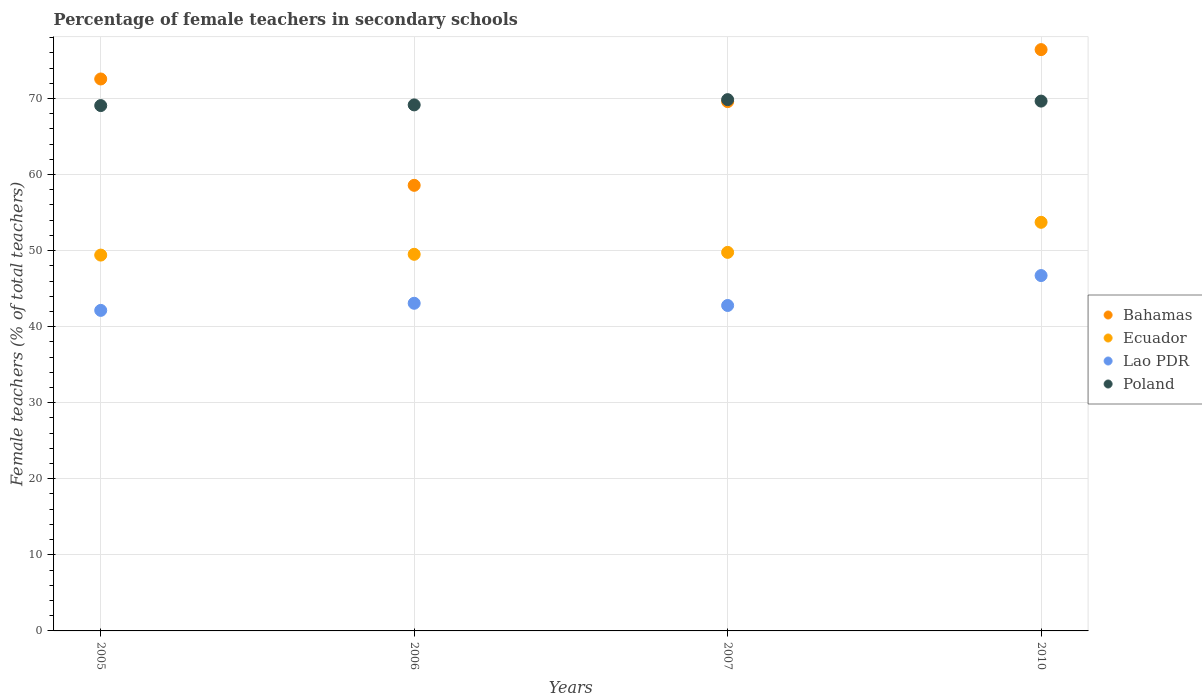Is the number of dotlines equal to the number of legend labels?
Provide a succinct answer. Yes. What is the percentage of female teachers in Ecuador in 2010?
Keep it short and to the point. 53.72. Across all years, what is the maximum percentage of female teachers in Lao PDR?
Offer a terse response. 46.72. Across all years, what is the minimum percentage of female teachers in Lao PDR?
Your answer should be compact. 42.14. In which year was the percentage of female teachers in Lao PDR maximum?
Offer a terse response. 2010. What is the total percentage of female teachers in Poland in the graph?
Your response must be concise. 277.71. What is the difference between the percentage of female teachers in Ecuador in 2005 and that in 2010?
Keep it short and to the point. -4.31. What is the difference between the percentage of female teachers in Lao PDR in 2006 and the percentage of female teachers in Ecuador in 2007?
Provide a short and direct response. -6.69. What is the average percentage of female teachers in Bahamas per year?
Your answer should be compact. 69.28. In the year 2005, what is the difference between the percentage of female teachers in Poland and percentage of female teachers in Ecuador?
Make the answer very short. 19.66. What is the ratio of the percentage of female teachers in Ecuador in 2007 to that in 2010?
Provide a short and direct response. 0.93. Is the difference between the percentage of female teachers in Poland in 2006 and 2007 greater than the difference between the percentage of female teachers in Ecuador in 2006 and 2007?
Your response must be concise. No. What is the difference between the highest and the second highest percentage of female teachers in Bahamas?
Provide a succinct answer. 3.86. What is the difference between the highest and the lowest percentage of female teachers in Lao PDR?
Provide a succinct answer. 4.58. In how many years, is the percentage of female teachers in Poland greater than the average percentage of female teachers in Poland taken over all years?
Your answer should be very brief. 2. Is it the case that in every year, the sum of the percentage of female teachers in Ecuador and percentage of female teachers in Lao PDR  is greater than the sum of percentage of female teachers in Bahamas and percentage of female teachers in Poland?
Your response must be concise. No. Does the percentage of female teachers in Ecuador monotonically increase over the years?
Your response must be concise. Yes. Is the percentage of female teachers in Bahamas strictly less than the percentage of female teachers in Ecuador over the years?
Offer a terse response. No. How many years are there in the graph?
Keep it short and to the point. 4. What is the difference between two consecutive major ticks on the Y-axis?
Provide a short and direct response. 10. Does the graph contain grids?
Keep it short and to the point. Yes. How many legend labels are there?
Offer a very short reply. 4. What is the title of the graph?
Provide a succinct answer. Percentage of female teachers in secondary schools. What is the label or title of the X-axis?
Ensure brevity in your answer.  Years. What is the label or title of the Y-axis?
Provide a short and direct response. Female teachers (% of total teachers). What is the Female teachers (% of total teachers) of Bahamas in 2005?
Provide a short and direct response. 72.56. What is the Female teachers (% of total teachers) in Ecuador in 2005?
Your answer should be compact. 49.41. What is the Female teachers (% of total teachers) in Lao PDR in 2005?
Ensure brevity in your answer.  42.14. What is the Female teachers (% of total teachers) of Poland in 2005?
Your answer should be compact. 69.06. What is the Female teachers (% of total teachers) of Bahamas in 2006?
Ensure brevity in your answer.  58.58. What is the Female teachers (% of total teachers) in Ecuador in 2006?
Keep it short and to the point. 49.51. What is the Female teachers (% of total teachers) in Lao PDR in 2006?
Provide a short and direct response. 43.07. What is the Female teachers (% of total teachers) of Poland in 2006?
Provide a succinct answer. 69.15. What is the Female teachers (% of total teachers) of Bahamas in 2007?
Provide a succinct answer. 69.58. What is the Female teachers (% of total teachers) of Ecuador in 2007?
Your answer should be compact. 49.76. What is the Female teachers (% of total teachers) of Lao PDR in 2007?
Your answer should be very brief. 42.78. What is the Female teachers (% of total teachers) in Poland in 2007?
Ensure brevity in your answer.  69.84. What is the Female teachers (% of total teachers) in Bahamas in 2010?
Give a very brief answer. 76.42. What is the Female teachers (% of total teachers) in Ecuador in 2010?
Your answer should be compact. 53.72. What is the Female teachers (% of total teachers) of Lao PDR in 2010?
Your answer should be compact. 46.72. What is the Female teachers (% of total teachers) in Poland in 2010?
Your answer should be compact. 69.65. Across all years, what is the maximum Female teachers (% of total teachers) of Bahamas?
Give a very brief answer. 76.42. Across all years, what is the maximum Female teachers (% of total teachers) of Ecuador?
Give a very brief answer. 53.72. Across all years, what is the maximum Female teachers (% of total teachers) of Lao PDR?
Keep it short and to the point. 46.72. Across all years, what is the maximum Female teachers (% of total teachers) of Poland?
Your answer should be very brief. 69.84. Across all years, what is the minimum Female teachers (% of total teachers) in Bahamas?
Ensure brevity in your answer.  58.58. Across all years, what is the minimum Female teachers (% of total teachers) in Ecuador?
Your answer should be very brief. 49.41. Across all years, what is the minimum Female teachers (% of total teachers) in Lao PDR?
Your response must be concise. 42.14. Across all years, what is the minimum Female teachers (% of total teachers) of Poland?
Give a very brief answer. 69.06. What is the total Female teachers (% of total teachers) in Bahamas in the graph?
Provide a short and direct response. 277.14. What is the total Female teachers (% of total teachers) in Ecuador in the graph?
Make the answer very short. 202.4. What is the total Female teachers (% of total teachers) in Lao PDR in the graph?
Your answer should be compact. 174.71. What is the total Female teachers (% of total teachers) in Poland in the graph?
Provide a succinct answer. 277.71. What is the difference between the Female teachers (% of total teachers) of Bahamas in 2005 and that in 2006?
Give a very brief answer. 13.98. What is the difference between the Female teachers (% of total teachers) of Ecuador in 2005 and that in 2006?
Your answer should be compact. -0.1. What is the difference between the Female teachers (% of total teachers) of Lao PDR in 2005 and that in 2006?
Your answer should be compact. -0.94. What is the difference between the Female teachers (% of total teachers) in Poland in 2005 and that in 2006?
Offer a very short reply. -0.09. What is the difference between the Female teachers (% of total teachers) of Bahamas in 2005 and that in 2007?
Ensure brevity in your answer.  2.97. What is the difference between the Female teachers (% of total teachers) of Ecuador in 2005 and that in 2007?
Provide a succinct answer. -0.36. What is the difference between the Female teachers (% of total teachers) in Lao PDR in 2005 and that in 2007?
Keep it short and to the point. -0.64. What is the difference between the Female teachers (% of total teachers) in Poland in 2005 and that in 2007?
Keep it short and to the point. -0.78. What is the difference between the Female teachers (% of total teachers) in Bahamas in 2005 and that in 2010?
Give a very brief answer. -3.86. What is the difference between the Female teachers (% of total teachers) in Ecuador in 2005 and that in 2010?
Ensure brevity in your answer.  -4.31. What is the difference between the Female teachers (% of total teachers) in Lao PDR in 2005 and that in 2010?
Provide a succinct answer. -4.58. What is the difference between the Female teachers (% of total teachers) in Poland in 2005 and that in 2010?
Ensure brevity in your answer.  -0.59. What is the difference between the Female teachers (% of total teachers) in Bahamas in 2006 and that in 2007?
Provide a short and direct response. -11.01. What is the difference between the Female teachers (% of total teachers) in Ecuador in 2006 and that in 2007?
Ensure brevity in your answer.  -0.25. What is the difference between the Female teachers (% of total teachers) in Lao PDR in 2006 and that in 2007?
Offer a very short reply. 0.29. What is the difference between the Female teachers (% of total teachers) in Poland in 2006 and that in 2007?
Give a very brief answer. -0.69. What is the difference between the Female teachers (% of total teachers) of Bahamas in 2006 and that in 2010?
Your answer should be very brief. -17.84. What is the difference between the Female teachers (% of total teachers) of Ecuador in 2006 and that in 2010?
Make the answer very short. -4.21. What is the difference between the Female teachers (% of total teachers) in Lao PDR in 2006 and that in 2010?
Provide a short and direct response. -3.64. What is the difference between the Female teachers (% of total teachers) of Poland in 2006 and that in 2010?
Your answer should be compact. -0.5. What is the difference between the Female teachers (% of total teachers) of Bahamas in 2007 and that in 2010?
Your answer should be compact. -6.83. What is the difference between the Female teachers (% of total teachers) in Ecuador in 2007 and that in 2010?
Your answer should be very brief. -3.95. What is the difference between the Female teachers (% of total teachers) of Lao PDR in 2007 and that in 2010?
Give a very brief answer. -3.93. What is the difference between the Female teachers (% of total teachers) in Poland in 2007 and that in 2010?
Give a very brief answer. 0.19. What is the difference between the Female teachers (% of total teachers) in Bahamas in 2005 and the Female teachers (% of total teachers) in Ecuador in 2006?
Ensure brevity in your answer.  23.05. What is the difference between the Female teachers (% of total teachers) of Bahamas in 2005 and the Female teachers (% of total teachers) of Lao PDR in 2006?
Provide a short and direct response. 29.49. What is the difference between the Female teachers (% of total teachers) in Bahamas in 2005 and the Female teachers (% of total teachers) in Poland in 2006?
Keep it short and to the point. 3.41. What is the difference between the Female teachers (% of total teachers) in Ecuador in 2005 and the Female teachers (% of total teachers) in Lao PDR in 2006?
Ensure brevity in your answer.  6.33. What is the difference between the Female teachers (% of total teachers) of Ecuador in 2005 and the Female teachers (% of total teachers) of Poland in 2006?
Keep it short and to the point. -19.75. What is the difference between the Female teachers (% of total teachers) of Lao PDR in 2005 and the Female teachers (% of total teachers) of Poland in 2006?
Keep it short and to the point. -27.01. What is the difference between the Female teachers (% of total teachers) of Bahamas in 2005 and the Female teachers (% of total teachers) of Ecuador in 2007?
Your answer should be compact. 22.79. What is the difference between the Female teachers (% of total teachers) in Bahamas in 2005 and the Female teachers (% of total teachers) in Lao PDR in 2007?
Your answer should be very brief. 29.78. What is the difference between the Female teachers (% of total teachers) of Bahamas in 2005 and the Female teachers (% of total teachers) of Poland in 2007?
Make the answer very short. 2.72. What is the difference between the Female teachers (% of total teachers) of Ecuador in 2005 and the Female teachers (% of total teachers) of Lao PDR in 2007?
Your response must be concise. 6.62. What is the difference between the Female teachers (% of total teachers) of Ecuador in 2005 and the Female teachers (% of total teachers) of Poland in 2007?
Keep it short and to the point. -20.44. What is the difference between the Female teachers (% of total teachers) in Lao PDR in 2005 and the Female teachers (% of total teachers) in Poland in 2007?
Your response must be concise. -27.7. What is the difference between the Female teachers (% of total teachers) of Bahamas in 2005 and the Female teachers (% of total teachers) of Ecuador in 2010?
Offer a very short reply. 18.84. What is the difference between the Female teachers (% of total teachers) in Bahamas in 2005 and the Female teachers (% of total teachers) in Lao PDR in 2010?
Your answer should be very brief. 25.84. What is the difference between the Female teachers (% of total teachers) of Bahamas in 2005 and the Female teachers (% of total teachers) of Poland in 2010?
Provide a succinct answer. 2.91. What is the difference between the Female teachers (% of total teachers) of Ecuador in 2005 and the Female teachers (% of total teachers) of Lao PDR in 2010?
Your response must be concise. 2.69. What is the difference between the Female teachers (% of total teachers) of Ecuador in 2005 and the Female teachers (% of total teachers) of Poland in 2010?
Offer a very short reply. -20.24. What is the difference between the Female teachers (% of total teachers) in Lao PDR in 2005 and the Female teachers (% of total teachers) in Poland in 2010?
Give a very brief answer. -27.51. What is the difference between the Female teachers (% of total teachers) of Bahamas in 2006 and the Female teachers (% of total teachers) of Ecuador in 2007?
Offer a very short reply. 8.81. What is the difference between the Female teachers (% of total teachers) in Bahamas in 2006 and the Female teachers (% of total teachers) in Lao PDR in 2007?
Your response must be concise. 15.8. What is the difference between the Female teachers (% of total teachers) of Bahamas in 2006 and the Female teachers (% of total teachers) of Poland in 2007?
Ensure brevity in your answer.  -11.26. What is the difference between the Female teachers (% of total teachers) in Ecuador in 2006 and the Female teachers (% of total teachers) in Lao PDR in 2007?
Your answer should be very brief. 6.73. What is the difference between the Female teachers (% of total teachers) of Ecuador in 2006 and the Female teachers (% of total teachers) of Poland in 2007?
Give a very brief answer. -20.33. What is the difference between the Female teachers (% of total teachers) in Lao PDR in 2006 and the Female teachers (% of total teachers) in Poland in 2007?
Give a very brief answer. -26.77. What is the difference between the Female teachers (% of total teachers) in Bahamas in 2006 and the Female teachers (% of total teachers) in Ecuador in 2010?
Make the answer very short. 4.86. What is the difference between the Female teachers (% of total teachers) of Bahamas in 2006 and the Female teachers (% of total teachers) of Lao PDR in 2010?
Your answer should be compact. 11.86. What is the difference between the Female teachers (% of total teachers) of Bahamas in 2006 and the Female teachers (% of total teachers) of Poland in 2010?
Make the answer very short. -11.07. What is the difference between the Female teachers (% of total teachers) in Ecuador in 2006 and the Female teachers (% of total teachers) in Lao PDR in 2010?
Offer a terse response. 2.79. What is the difference between the Female teachers (% of total teachers) of Ecuador in 2006 and the Female teachers (% of total teachers) of Poland in 2010?
Provide a succinct answer. -20.14. What is the difference between the Female teachers (% of total teachers) of Lao PDR in 2006 and the Female teachers (% of total teachers) of Poland in 2010?
Make the answer very short. -26.58. What is the difference between the Female teachers (% of total teachers) in Bahamas in 2007 and the Female teachers (% of total teachers) in Ecuador in 2010?
Your answer should be compact. 15.87. What is the difference between the Female teachers (% of total teachers) of Bahamas in 2007 and the Female teachers (% of total teachers) of Lao PDR in 2010?
Offer a terse response. 22.87. What is the difference between the Female teachers (% of total teachers) of Bahamas in 2007 and the Female teachers (% of total teachers) of Poland in 2010?
Make the answer very short. -0.07. What is the difference between the Female teachers (% of total teachers) in Ecuador in 2007 and the Female teachers (% of total teachers) in Lao PDR in 2010?
Offer a terse response. 3.05. What is the difference between the Female teachers (% of total teachers) in Ecuador in 2007 and the Female teachers (% of total teachers) in Poland in 2010?
Your answer should be very brief. -19.89. What is the difference between the Female teachers (% of total teachers) of Lao PDR in 2007 and the Female teachers (% of total teachers) of Poland in 2010?
Provide a short and direct response. -26.87. What is the average Female teachers (% of total teachers) of Bahamas per year?
Provide a succinct answer. 69.28. What is the average Female teachers (% of total teachers) in Ecuador per year?
Ensure brevity in your answer.  50.6. What is the average Female teachers (% of total teachers) in Lao PDR per year?
Offer a very short reply. 43.68. What is the average Female teachers (% of total teachers) of Poland per year?
Ensure brevity in your answer.  69.43. In the year 2005, what is the difference between the Female teachers (% of total teachers) in Bahamas and Female teachers (% of total teachers) in Ecuador?
Keep it short and to the point. 23.15. In the year 2005, what is the difference between the Female teachers (% of total teachers) of Bahamas and Female teachers (% of total teachers) of Lao PDR?
Give a very brief answer. 30.42. In the year 2005, what is the difference between the Female teachers (% of total teachers) of Bahamas and Female teachers (% of total teachers) of Poland?
Provide a succinct answer. 3.5. In the year 2005, what is the difference between the Female teachers (% of total teachers) in Ecuador and Female teachers (% of total teachers) in Lao PDR?
Your answer should be compact. 7.27. In the year 2005, what is the difference between the Female teachers (% of total teachers) in Ecuador and Female teachers (% of total teachers) in Poland?
Make the answer very short. -19.66. In the year 2005, what is the difference between the Female teachers (% of total teachers) in Lao PDR and Female teachers (% of total teachers) in Poland?
Provide a succinct answer. -26.92. In the year 2006, what is the difference between the Female teachers (% of total teachers) in Bahamas and Female teachers (% of total teachers) in Ecuador?
Your answer should be very brief. 9.07. In the year 2006, what is the difference between the Female teachers (% of total teachers) of Bahamas and Female teachers (% of total teachers) of Lao PDR?
Keep it short and to the point. 15.51. In the year 2006, what is the difference between the Female teachers (% of total teachers) of Bahamas and Female teachers (% of total teachers) of Poland?
Your response must be concise. -10.57. In the year 2006, what is the difference between the Female teachers (% of total teachers) in Ecuador and Female teachers (% of total teachers) in Lao PDR?
Give a very brief answer. 6.44. In the year 2006, what is the difference between the Female teachers (% of total teachers) of Ecuador and Female teachers (% of total teachers) of Poland?
Keep it short and to the point. -19.64. In the year 2006, what is the difference between the Female teachers (% of total teachers) in Lao PDR and Female teachers (% of total teachers) in Poland?
Ensure brevity in your answer.  -26.08. In the year 2007, what is the difference between the Female teachers (% of total teachers) of Bahamas and Female teachers (% of total teachers) of Ecuador?
Your response must be concise. 19.82. In the year 2007, what is the difference between the Female teachers (% of total teachers) of Bahamas and Female teachers (% of total teachers) of Lao PDR?
Ensure brevity in your answer.  26.8. In the year 2007, what is the difference between the Female teachers (% of total teachers) in Bahamas and Female teachers (% of total teachers) in Poland?
Make the answer very short. -0.26. In the year 2007, what is the difference between the Female teachers (% of total teachers) in Ecuador and Female teachers (% of total teachers) in Lao PDR?
Make the answer very short. 6.98. In the year 2007, what is the difference between the Female teachers (% of total teachers) in Ecuador and Female teachers (% of total teachers) in Poland?
Your answer should be very brief. -20.08. In the year 2007, what is the difference between the Female teachers (% of total teachers) in Lao PDR and Female teachers (% of total teachers) in Poland?
Your answer should be very brief. -27.06. In the year 2010, what is the difference between the Female teachers (% of total teachers) in Bahamas and Female teachers (% of total teachers) in Ecuador?
Give a very brief answer. 22.7. In the year 2010, what is the difference between the Female teachers (% of total teachers) in Bahamas and Female teachers (% of total teachers) in Lao PDR?
Ensure brevity in your answer.  29.7. In the year 2010, what is the difference between the Female teachers (% of total teachers) in Bahamas and Female teachers (% of total teachers) in Poland?
Offer a terse response. 6.77. In the year 2010, what is the difference between the Female teachers (% of total teachers) of Ecuador and Female teachers (% of total teachers) of Lao PDR?
Provide a succinct answer. 7. In the year 2010, what is the difference between the Female teachers (% of total teachers) of Ecuador and Female teachers (% of total teachers) of Poland?
Your answer should be compact. -15.93. In the year 2010, what is the difference between the Female teachers (% of total teachers) in Lao PDR and Female teachers (% of total teachers) in Poland?
Provide a short and direct response. -22.93. What is the ratio of the Female teachers (% of total teachers) in Bahamas in 2005 to that in 2006?
Your response must be concise. 1.24. What is the ratio of the Female teachers (% of total teachers) in Lao PDR in 2005 to that in 2006?
Provide a succinct answer. 0.98. What is the ratio of the Female teachers (% of total teachers) in Bahamas in 2005 to that in 2007?
Make the answer very short. 1.04. What is the ratio of the Female teachers (% of total teachers) in Ecuador in 2005 to that in 2007?
Provide a succinct answer. 0.99. What is the ratio of the Female teachers (% of total teachers) of Lao PDR in 2005 to that in 2007?
Give a very brief answer. 0.98. What is the ratio of the Female teachers (% of total teachers) of Bahamas in 2005 to that in 2010?
Your answer should be very brief. 0.95. What is the ratio of the Female teachers (% of total teachers) of Ecuador in 2005 to that in 2010?
Offer a very short reply. 0.92. What is the ratio of the Female teachers (% of total teachers) in Lao PDR in 2005 to that in 2010?
Your answer should be very brief. 0.9. What is the ratio of the Female teachers (% of total teachers) of Bahamas in 2006 to that in 2007?
Ensure brevity in your answer.  0.84. What is the ratio of the Female teachers (% of total teachers) of Ecuador in 2006 to that in 2007?
Ensure brevity in your answer.  0.99. What is the ratio of the Female teachers (% of total teachers) in Lao PDR in 2006 to that in 2007?
Give a very brief answer. 1.01. What is the ratio of the Female teachers (% of total teachers) in Poland in 2006 to that in 2007?
Your answer should be compact. 0.99. What is the ratio of the Female teachers (% of total teachers) in Bahamas in 2006 to that in 2010?
Give a very brief answer. 0.77. What is the ratio of the Female teachers (% of total teachers) in Ecuador in 2006 to that in 2010?
Give a very brief answer. 0.92. What is the ratio of the Female teachers (% of total teachers) in Lao PDR in 2006 to that in 2010?
Ensure brevity in your answer.  0.92. What is the ratio of the Female teachers (% of total teachers) in Bahamas in 2007 to that in 2010?
Provide a short and direct response. 0.91. What is the ratio of the Female teachers (% of total teachers) in Ecuador in 2007 to that in 2010?
Provide a succinct answer. 0.93. What is the ratio of the Female teachers (% of total teachers) of Lao PDR in 2007 to that in 2010?
Your response must be concise. 0.92. What is the ratio of the Female teachers (% of total teachers) of Poland in 2007 to that in 2010?
Provide a succinct answer. 1. What is the difference between the highest and the second highest Female teachers (% of total teachers) of Bahamas?
Offer a terse response. 3.86. What is the difference between the highest and the second highest Female teachers (% of total teachers) in Ecuador?
Your response must be concise. 3.95. What is the difference between the highest and the second highest Female teachers (% of total teachers) of Lao PDR?
Your response must be concise. 3.64. What is the difference between the highest and the second highest Female teachers (% of total teachers) of Poland?
Make the answer very short. 0.19. What is the difference between the highest and the lowest Female teachers (% of total teachers) in Bahamas?
Provide a short and direct response. 17.84. What is the difference between the highest and the lowest Female teachers (% of total teachers) of Ecuador?
Your answer should be compact. 4.31. What is the difference between the highest and the lowest Female teachers (% of total teachers) in Lao PDR?
Give a very brief answer. 4.58. What is the difference between the highest and the lowest Female teachers (% of total teachers) in Poland?
Keep it short and to the point. 0.78. 